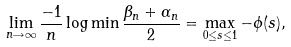Convert formula to latex. <formula><loc_0><loc_0><loc_500><loc_500>\lim _ { n \rightarrow \infty } \frac { - 1 } { n } \log \min \frac { \beta _ { n } + \alpha _ { n } } { 2 } = \max _ { 0 \leq s \leq 1 } - \phi ( s ) ,</formula> 